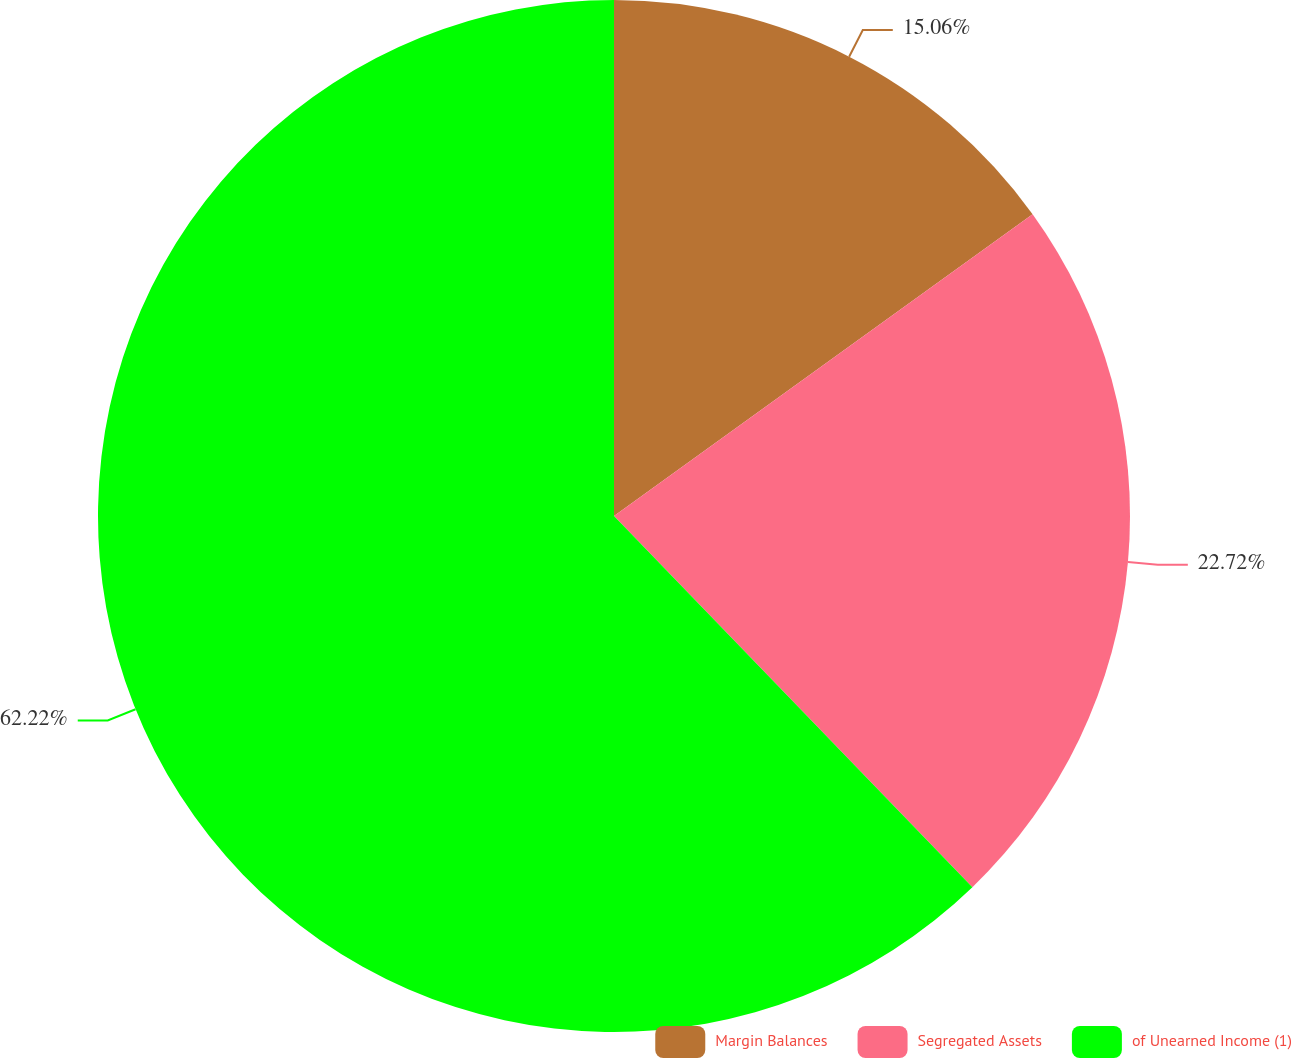Convert chart. <chart><loc_0><loc_0><loc_500><loc_500><pie_chart><fcel>Margin Balances<fcel>Segregated Assets<fcel>of Unearned Income (1)<nl><fcel>15.06%<fcel>22.72%<fcel>62.22%<nl></chart> 